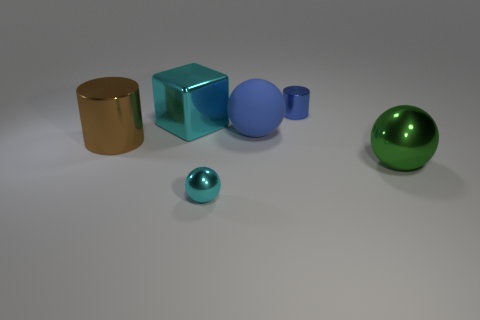Add 3 small cyan metal things. How many objects exist? 9 Subtract all cylinders. How many objects are left? 4 Add 2 cyan rubber things. How many cyan rubber things exist? 2 Subtract 0 red cylinders. How many objects are left? 6 Subtract all tiny red shiny blocks. Subtract all metal cylinders. How many objects are left? 4 Add 4 big blue matte objects. How many big blue matte objects are left? 5 